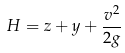<formula> <loc_0><loc_0><loc_500><loc_500>H = z + y + \frac { v ^ { 2 } } { 2 g }</formula> 